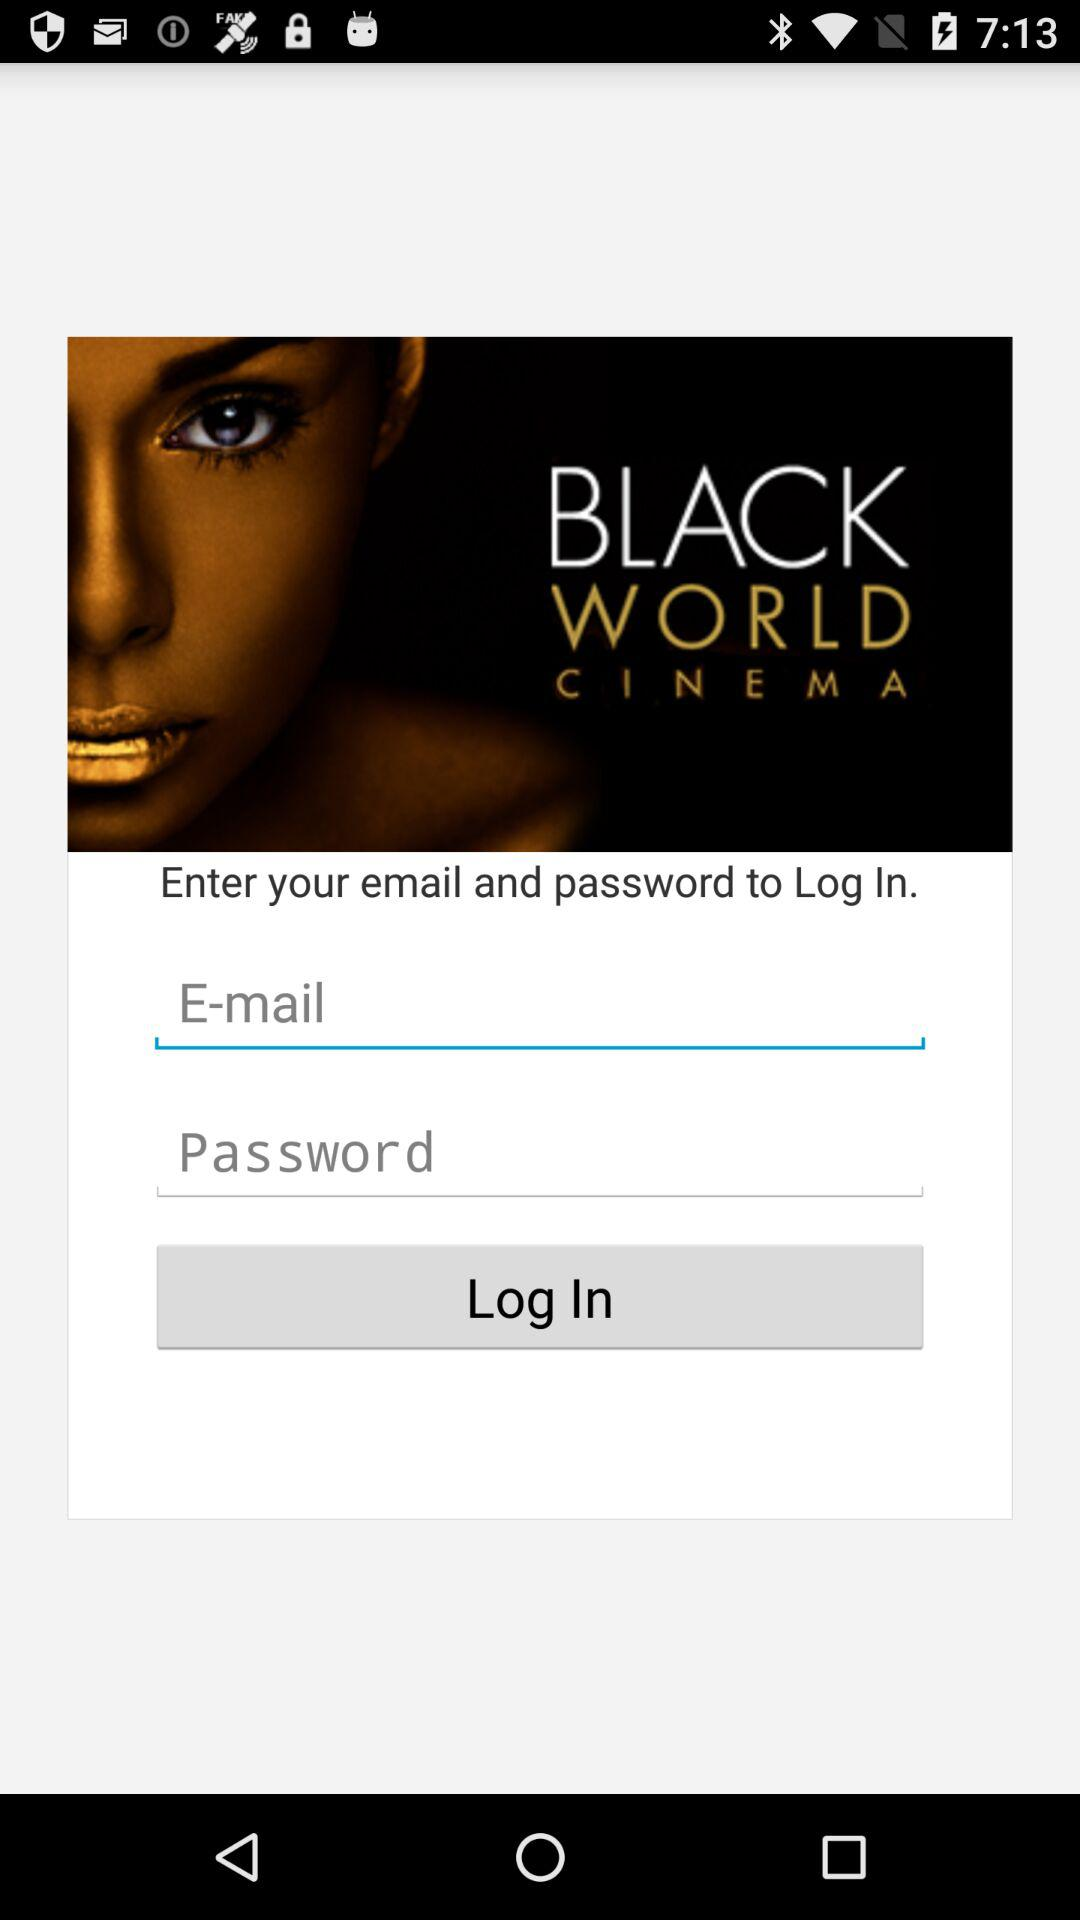How many input fields are there for logging in?
Answer the question using a single word or phrase. 2 